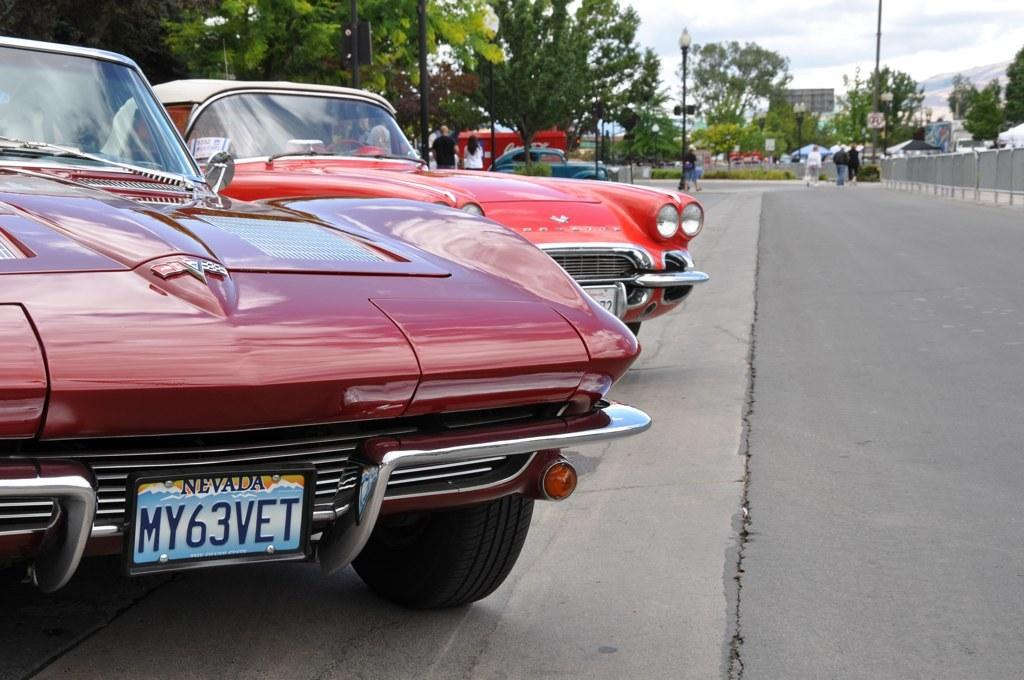What type of vehicles can be seen in the image? There are cars in the image. Who or what else is present in the image? There are people and trees in the image. What are the light poles used for in the image? The light poles are used for illuminating the area in the image. What is the primary surface that the cars are driving on in the image? There is a road in the image. What can be seen in the background of the image? The sky is visible in the background of the image. What type of cheese is being used to build the sand castle in the image? There is no sand castle or cheese present in the image. What color is the cream on the trees in the image? There is no cream on the trees in the image. 